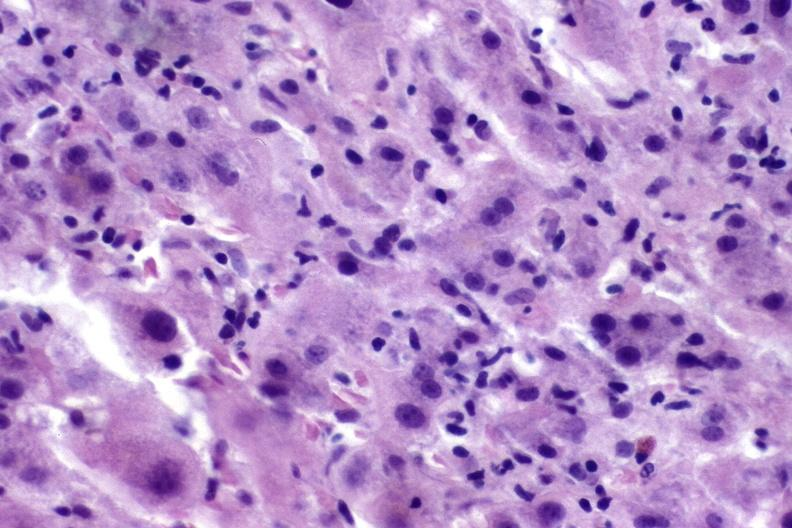what is present?
Answer the question using a single word or phrase. Liver 